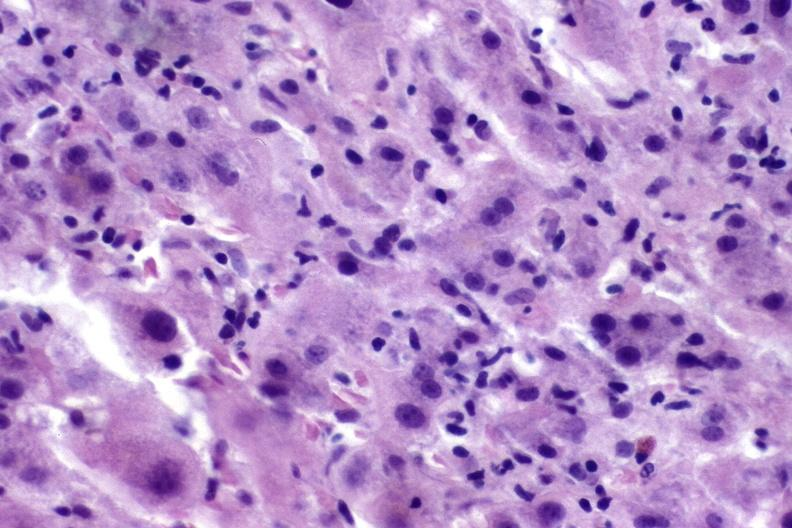what is present?
Answer the question using a single word or phrase. Liver 